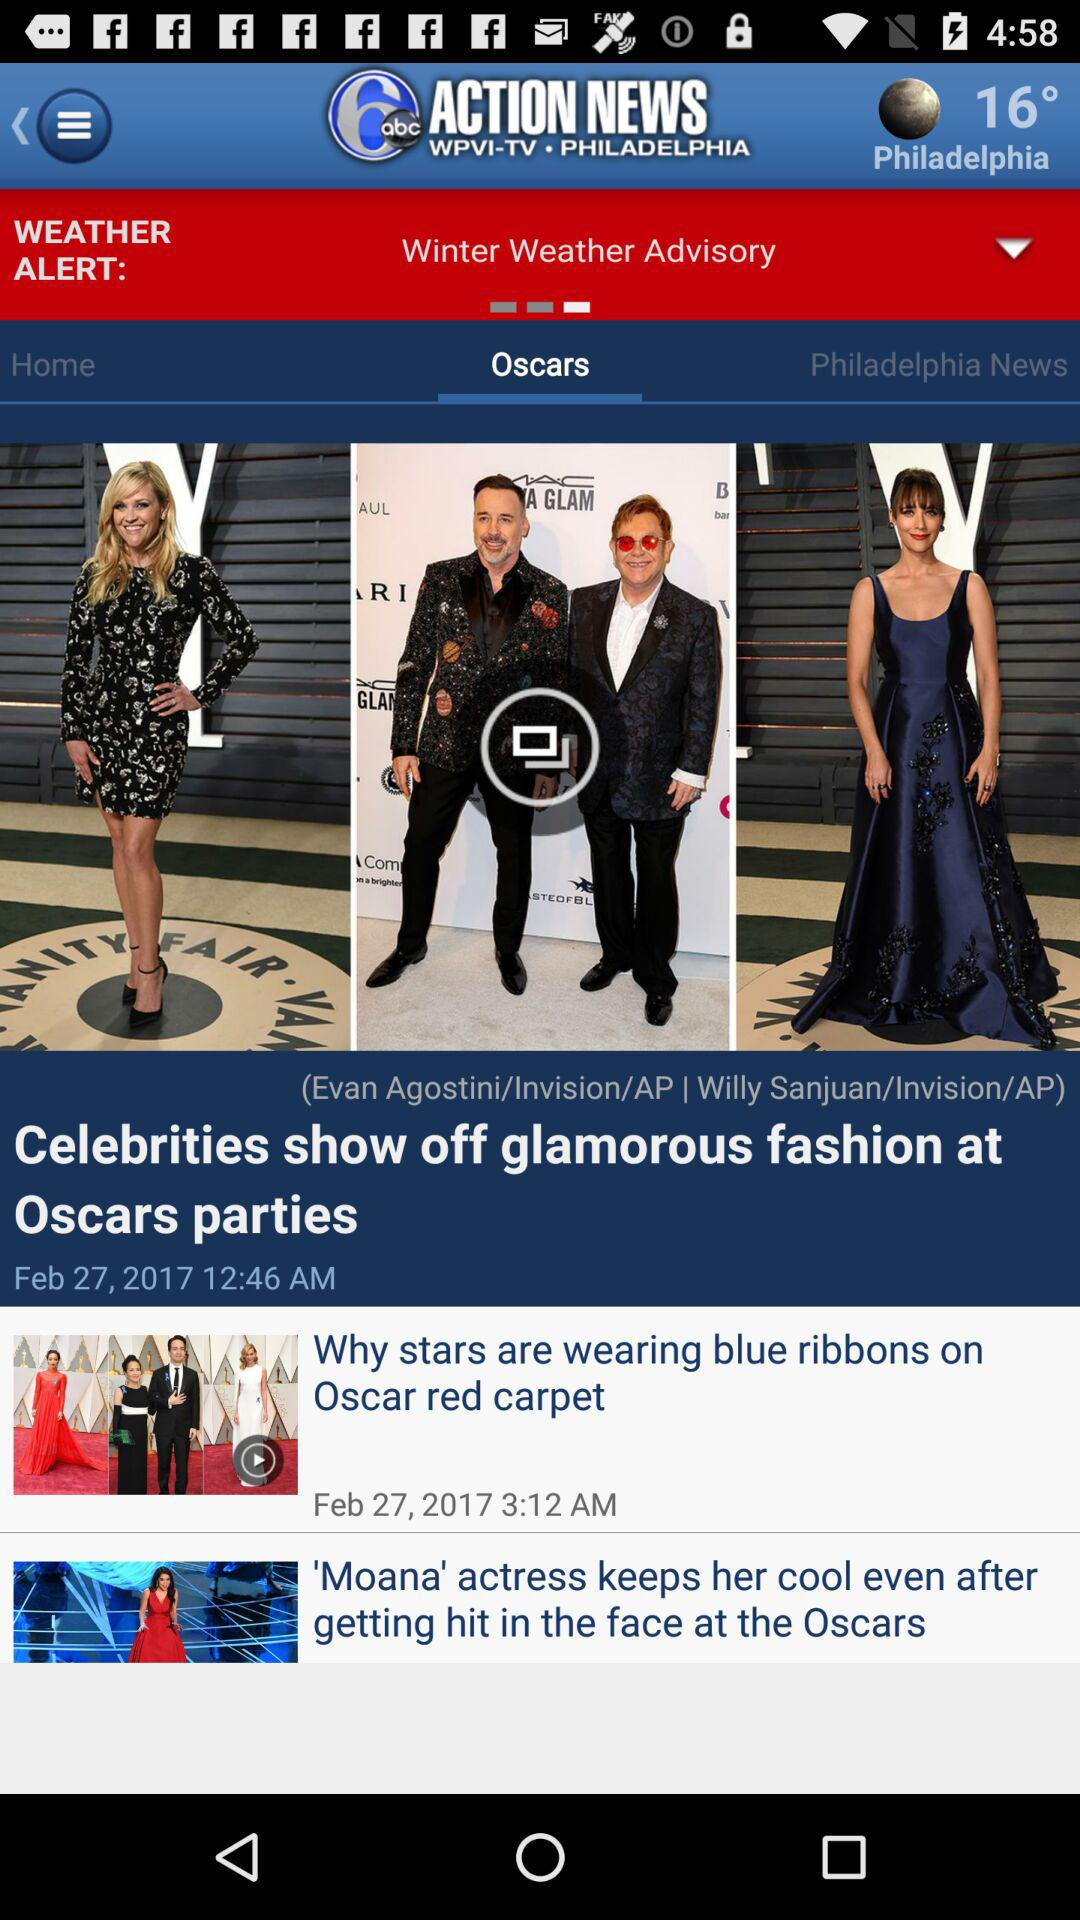How many stories are there in total?
Answer the question using a single word or phrase. 3 